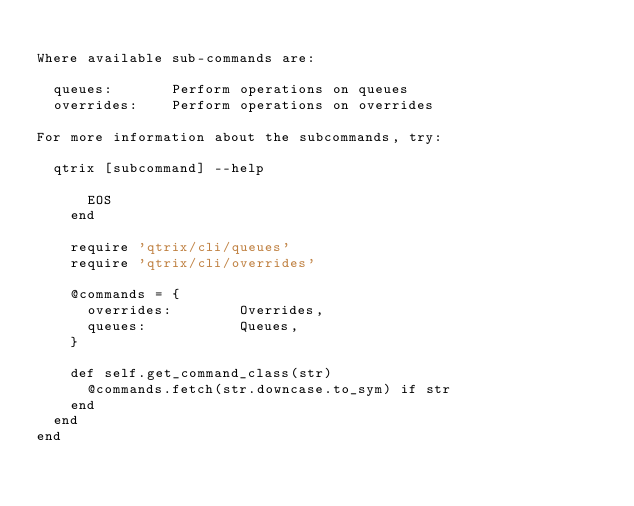Convert code to text. <code><loc_0><loc_0><loc_500><loc_500><_Ruby_>
Where available sub-commands are:

  queues:       Perform operations on queues
  overrides:    Perform operations on overrides

For more information about the subcommands, try:

  qtrix [subcommand] --help

      EOS
    end

    require 'qtrix/cli/queues'
    require 'qtrix/cli/overrides'

    @commands = {
      overrides:        Overrides,
      queues:           Queues,
    }

    def self.get_command_class(str)
      @commands.fetch(str.downcase.to_sym) if str
    end
  end
end

</code> 